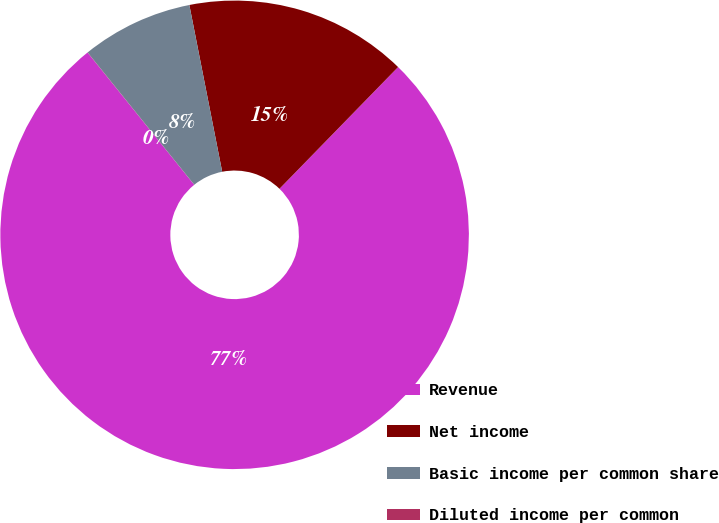Convert chart. <chart><loc_0><loc_0><loc_500><loc_500><pie_chart><fcel>Revenue<fcel>Net income<fcel>Basic income per common share<fcel>Diluted income per common<nl><fcel>76.9%<fcel>15.39%<fcel>7.7%<fcel>0.01%<nl></chart> 